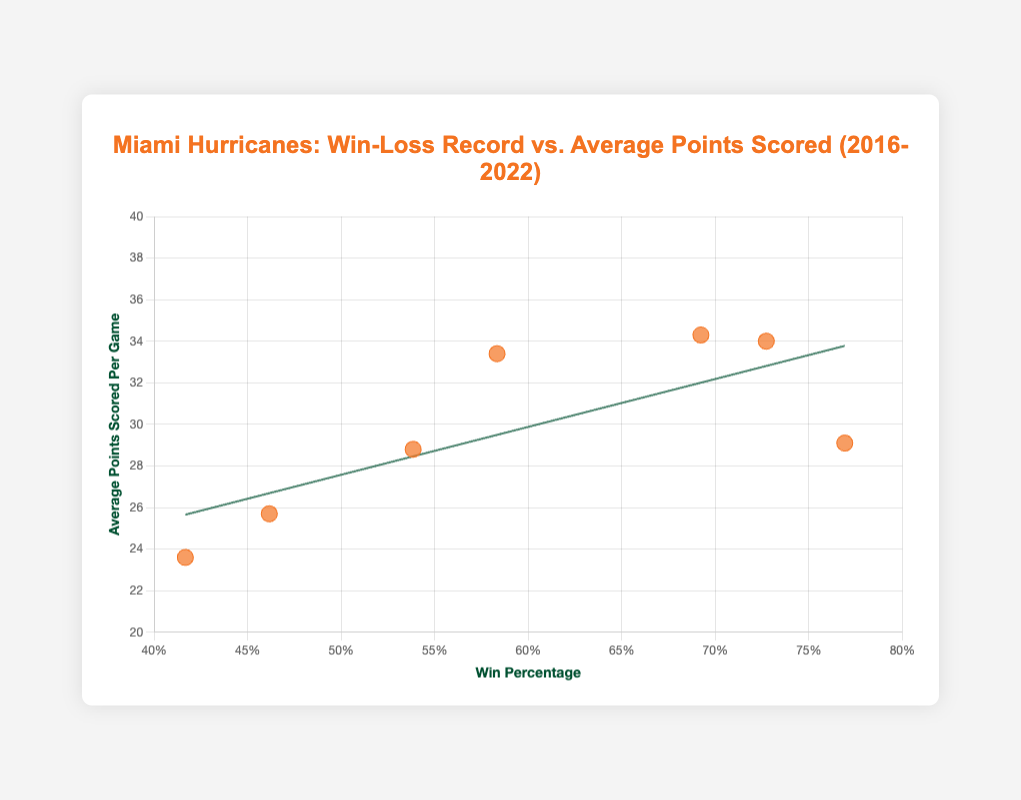Which season had the highest average points scored per game? To find the answer, look for the data point with the highest "y" value on the y-axis labeled "Average Points Scored Per Game." The highest point on the y-axis is the one corresponding to a value of 34.3, which occurs in the 2016 season.
Answer: 2016 What is the trend indicated by the trend line? To determine the trend, observe the slope of the trend line. If it rises from left to right, it indicates a positive correlation between win percentage and average points scored. In the figure, the trend line rises from left to right, indicating that higher win percentages are generally associated with more average points scored per game.
Answer: Positive correlation What season had a win-loss record closest to the 50% mark? To find the season closest to 50%, look for the data point nearest to 0.5 on the x-axis (Win Percentage). The point closest to 0.5 corresponds to the win-loss record of 7-6, which occurs in the 2018 season with a win percentage of approximately 0.538.
Answer: 2018 What is the average points scored per game for the 2022 season? To find the answer, locate the data point for the 2022 season and check the y-axis value it aligns with. The 2022 season has an average points scored per game value of 23.6.
Answer: 23.6 How does the win-loss record of 2017 compare with 2019 in terms of average points scored? To compare, locate the points for the 2017 and 2019 seasons on the scatter plot. 2017 has an average points scored of 29.1, while 2019 has 25.7. Therefore, the 2017 season had more average points scored per game than 2019.
Answer: 2017 scored more points What is the maximum average points scored among the seasons plotted? To find the maximum, identify the highest point on the y-axis labeled "Average Points Scored Per Game." The highest value is 34.3 points, which is visible on the plot.
Answer: 34.3 Is there a strong correlation between win percentage and average points scored? To assess the strength of the correlation, observe the clustering of data points around the trend line. If the points are closely clustered, the correlation is strong. In the figure, the data points are reasonably close to the trend line, indicating a moderate to strong correlation.
Answer: Yes How many seasons had an average points scored per game above 30? To answer this, count the number of points on the y-axis that are above the value 30. There are three such points visible in the plot, corresponding to the seasons 2016, 2020, and 2021.
Answer: 3 seasons 